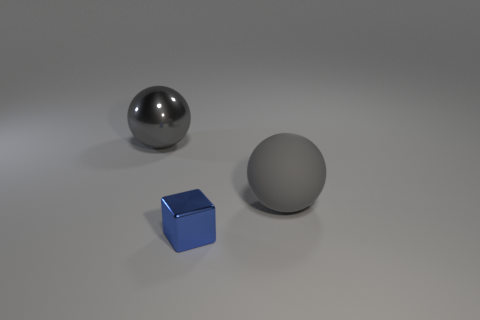Subtract all brown cubes. Subtract all red spheres. How many cubes are left? 1 Add 1 big rubber balls. How many objects exist? 4 Subtract all cubes. How many objects are left? 2 Subtract 0 red blocks. How many objects are left? 3 Subtract all tiny rubber objects. Subtract all blue metallic things. How many objects are left? 2 Add 1 tiny blue cubes. How many tiny blue cubes are left? 2 Add 3 gray balls. How many gray balls exist? 5 